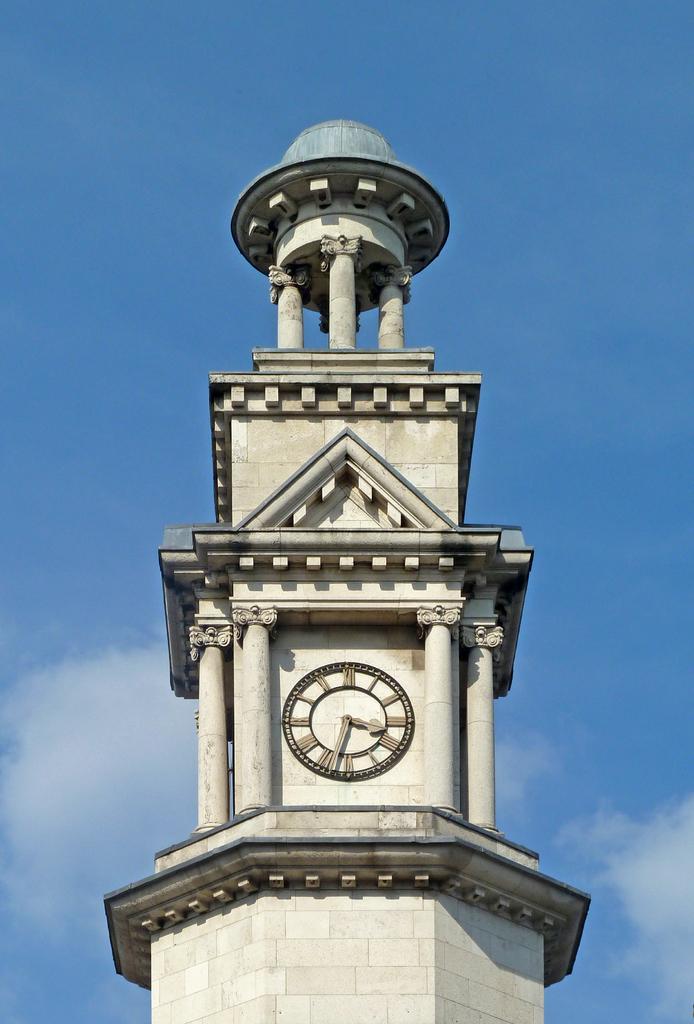What time does the clock say?
Provide a short and direct response. 3:33. 